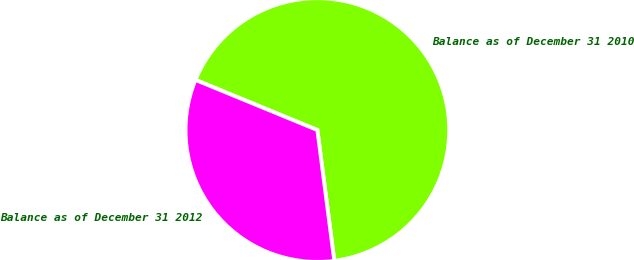Convert chart to OTSL. <chart><loc_0><loc_0><loc_500><loc_500><pie_chart><fcel>Balance as of December 31 2010<fcel>Balance as of December 31 2012<nl><fcel>66.74%<fcel>33.26%<nl></chart> 